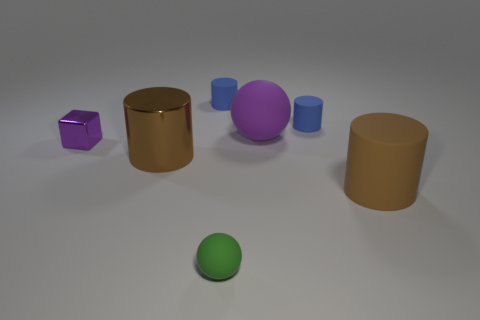Subtract 1 cylinders. How many cylinders are left? 3 Add 2 brown metallic objects. How many objects exist? 9 Subtract all balls. How many objects are left? 5 Subtract all big purple rubber spheres. Subtract all tiny blue objects. How many objects are left? 4 Add 1 tiny shiny cubes. How many tiny shiny cubes are left? 2 Add 1 small blue objects. How many small blue objects exist? 3 Subtract 0 red blocks. How many objects are left? 7 